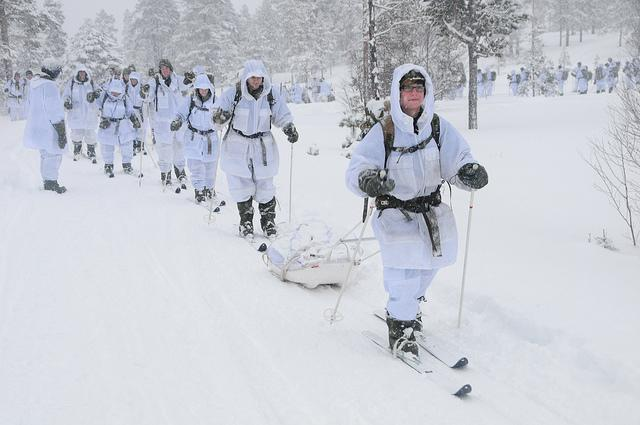What relation does the clothes here have? Please explain your reasoning. uniforms. The relation is the uniform. 